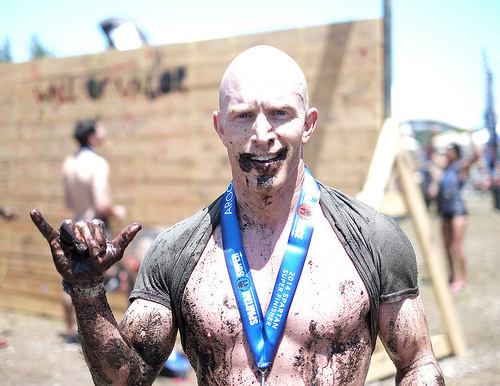<image>
Is the medal in the wall? No. The medal is not contained within the wall. These objects have a different spatial relationship. Is there a finger in front of the finger? No. The finger is not in front of the finger. The spatial positioning shows a different relationship between these objects. 